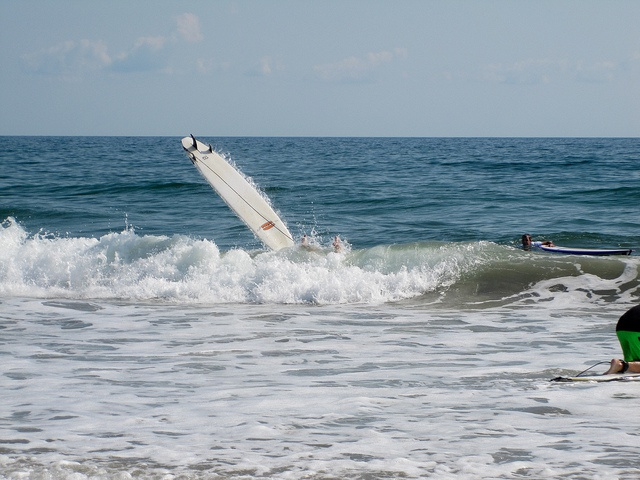Describe the objects in this image and their specific colors. I can see surfboard in darkgray, lightgray, and gray tones, people in darkgray, black, darkgreen, brown, and gray tones, surfboard in darkgray, lightgray, gray, and black tones, surfboard in darkgray, black, lightgray, and navy tones, and people in darkgray, black, gray, and blue tones in this image. 